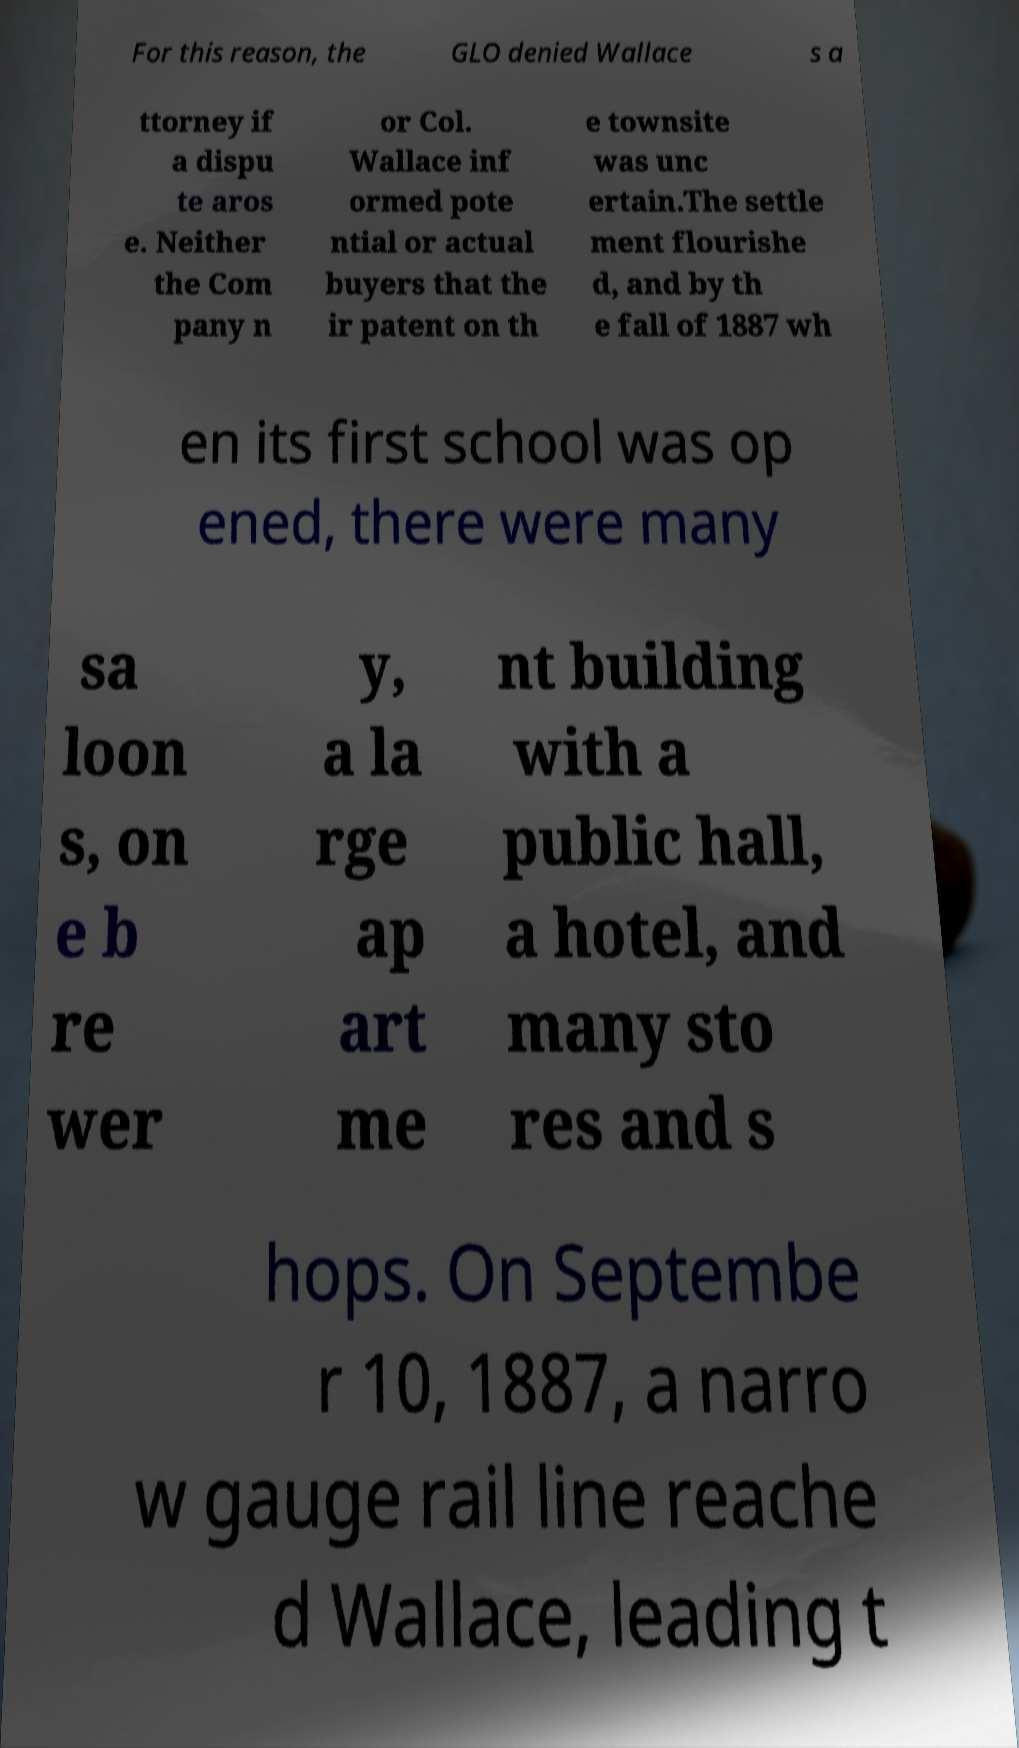Could you assist in decoding the text presented in this image and type it out clearly? For this reason, the GLO denied Wallace s a ttorney if a dispu te aros e. Neither the Com pany n or Col. Wallace inf ormed pote ntial or actual buyers that the ir patent on th e townsite was unc ertain.The settle ment flourishe d, and by th e fall of 1887 wh en its first school was op ened, there were many sa loon s, on e b re wer y, a la rge ap art me nt building with a public hall, a hotel, and many sto res and s hops. On Septembe r 10, 1887, a narro w gauge rail line reache d Wallace, leading t 